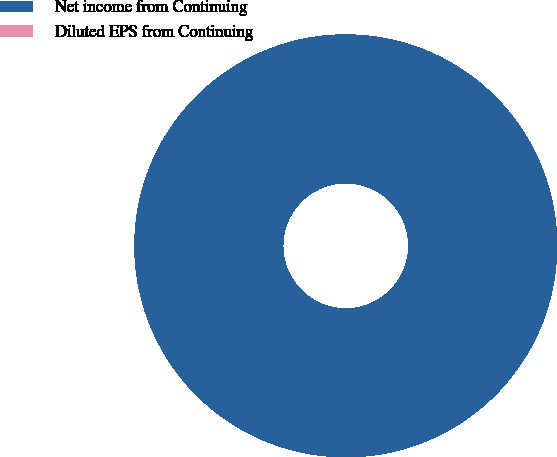<chart> <loc_0><loc_0><loc_500><loc_500><pie_chart><fcel>Net income from Continuing<fcel>Diluted EPS from Continuing<nl><fcel>100.0%<fcel>0.0%<nl></chart> 